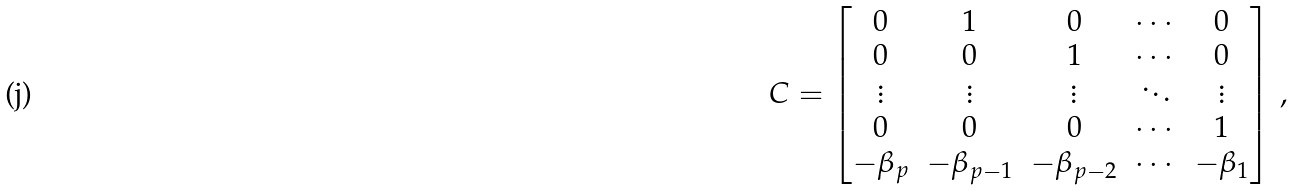Convert formula to latex. <formula><loc_0><loc_0><loc_500><loc_500>C = \begin{bmatrix} 0 & 1 & 0 & \cdots & 0 \\ 0 & 0 & 1 & \cdots & 0 \\ \vdots & \vdots & \vdots & \ddots & \vdots \\ 0 & 0 & 0 & \cdots & 1 \\ - \beta _ { p } & - \beta _ { p - 1 } & - \beta _ { p - 2 } & \cdots & - \beta _ { 1 } \end{bmatrix} \, ,</formula> 